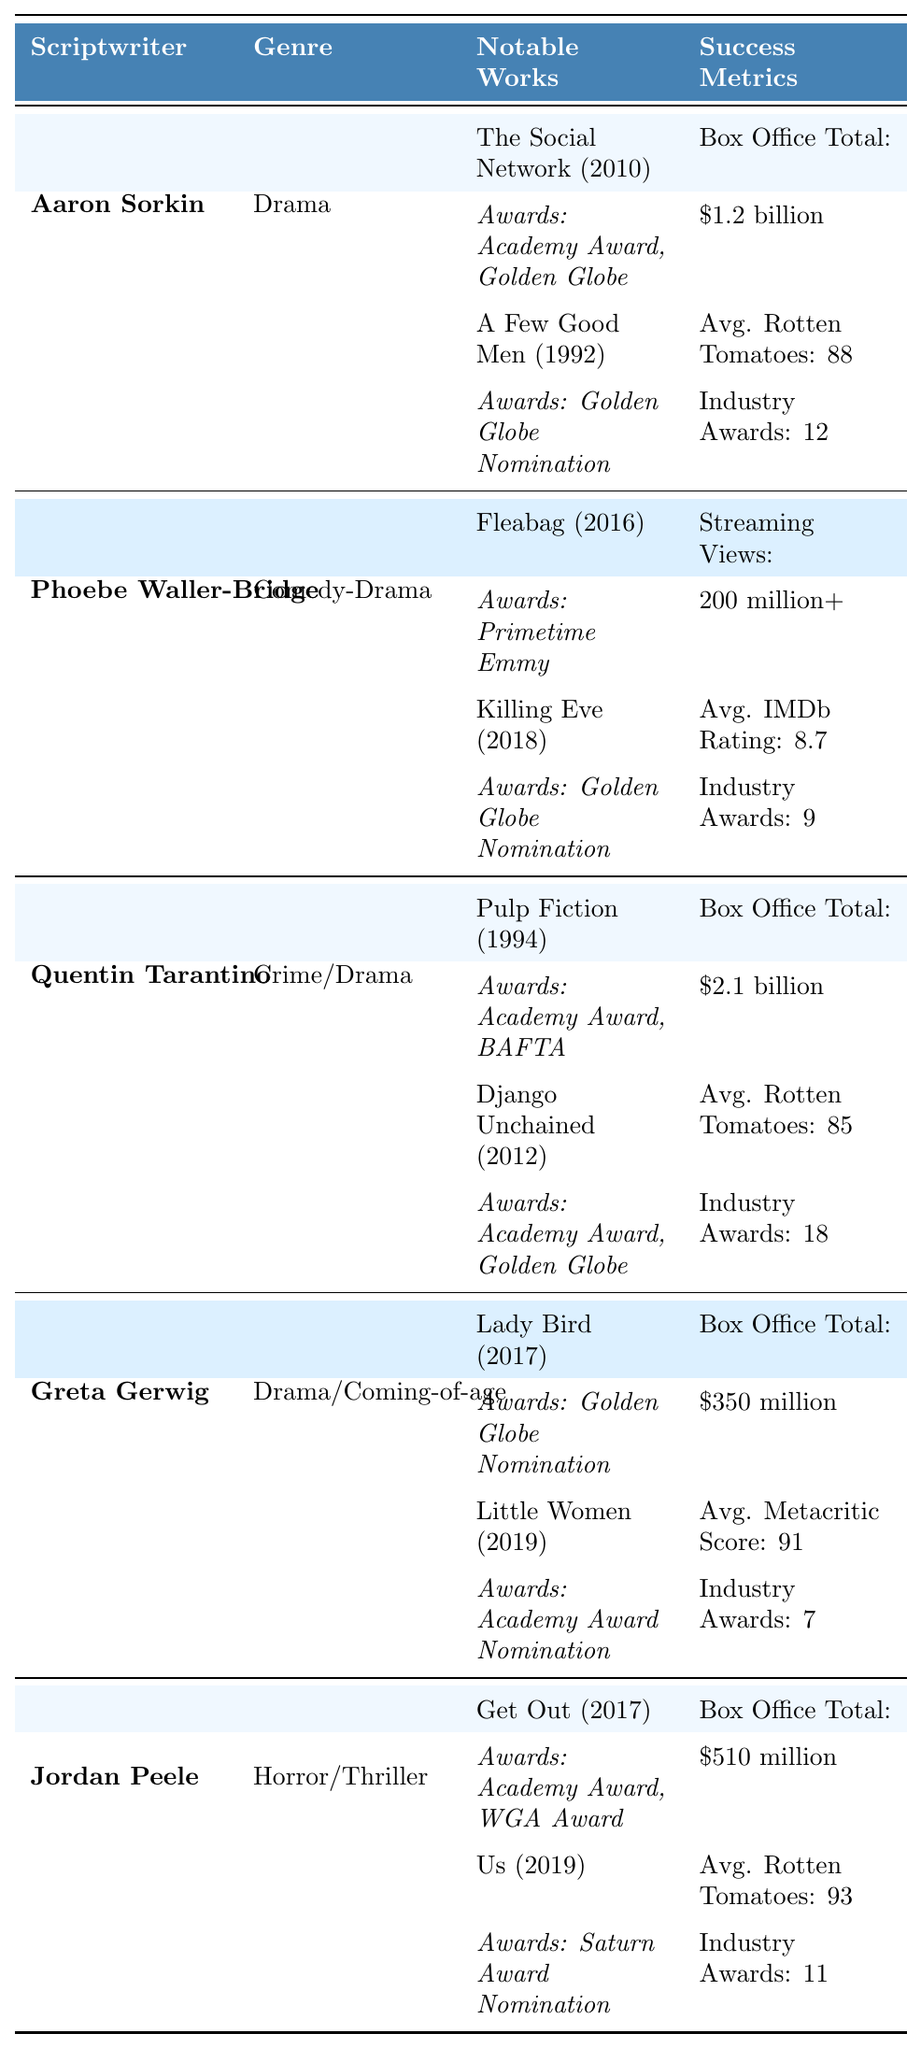What is the box office total for Aaron Sorkin's scripts? According to the table, Aaron Sorkin's box office total is listed as $1.2 billion.
Answer: $1.2 billion Which scriptwriter has the highest industry awards? By comparing the "Industry Awards" column, Quentin Tarantino has the highest total with 18 awards.
Answer: Quentin Tarantino What is the average Rotten Tomatoes score among the listed scriptwriters? The Rotten Tomatoes scores for scriptwriters are: 88 (Sorkin), 85 (Tarantino), and 93 (Peele). Adding these scores gives 88 + 85 + 93 = 266. Dividing by the number of scriptwriters (3), we get an average score of 266 / 3 = 88.67.
Answer: 88.67 Does Phoebe Waller-Bridge have more streaming views than the box office totals of Greta Gerwig's works? Greta Gerwig's box office total is $350 million, while Phoebe Waller-Bridge has 200 million+ streaming views. Since 200 million is less than $350 million, the statement is false.
Answer: No Which genre has the most total industry awards among the listed scriptwriters? The total industry awards per genre are: Drama (Sorkin 12 + Gerwig 7 = 19), Comedy-Drama (Waller-Bridge 9), Crime/Drama (Tarantino 18), and Horror/Thriller (Peele 11). Drama has the highest total with 19 awards.
Answer: Drama What year did Greta Gerwig's "Little Women" release? Looking at the notable works for Greta Gerwig, "Little Women" is listed with the year 2019.
Answer: 2019 Is there any scriptwriter in the table with a box office total below $500 million? The box office totals are as follows: Sorkin $1.2 billion, Tarantino $2.1 billion, Gerwig $350 million, and Peele $510 million. Gerwig's total is below $500 million, making the statement true.
Answer: Yes How many notable works does Quentin Tarantino have listed? The table shows that Quentin Tarantino has two notable works: "Pulp Fiction" and "Django Unchained."
Answer: 2 Which scriptwriter's notable work received a Primetime Emmy award? Looking through the notable works, Phoebe Waller-Bridge's "Fleabag" received a Primetime Emmy for Outstanding Writing for a Comedy Series.
Answer: Phoebe Waller-Bridge What is the total box office for both Aaron Sorkin and Quentin Tarantino combined? Sorkin's box office is $1.2 billion and Tarantino's is $2.1 billion. Adding these: $1.2 billion + $2.1 billion = $3.3 billion.
Answer: $3.3 billion 